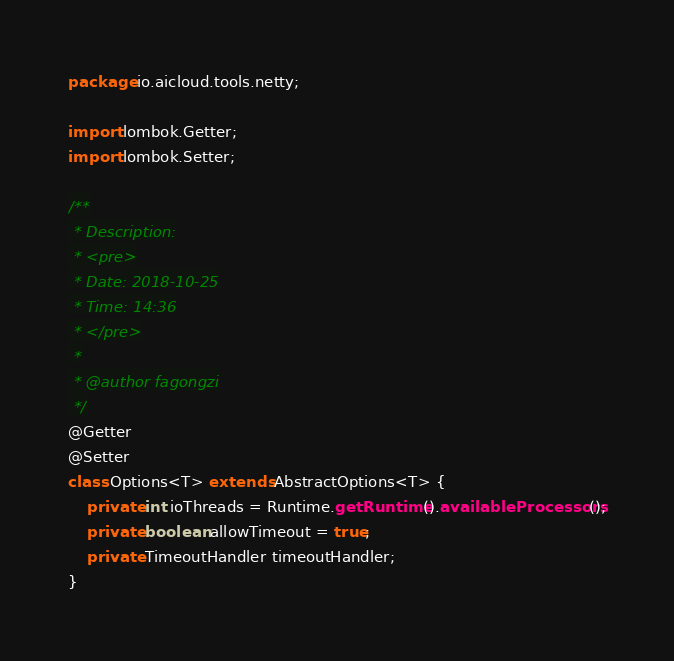Convert code to text. <code><loc_0><loc_0><loc_500><loc_500><_Java_>package io.aicloud.tools.netty;

import lombok.Getter;
import lombok.Setter;

/**
 * Description:
 * <pre>
 * Date: 2018-10-25
 * Time: 14:36
 * </pre>
 *
 * @author fagongzi
 */
@Getter
@Setter
class Options<T> extends AbstractOptions<T> {
    private int ioThreads = Runtime.getRuntime().availableProcessors();
    private boolean allowTimeout = true;
    private TimeoutHandler timeoutHandler;
}
</code> 